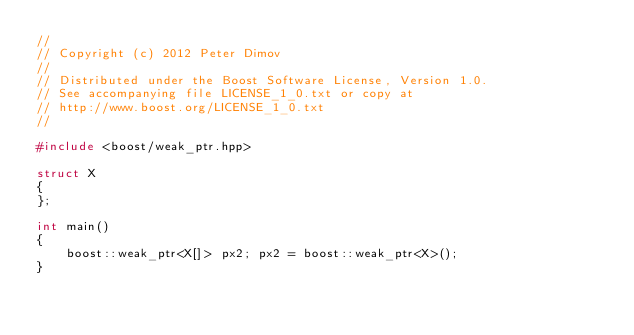Convert code to text. <code><loc_0><loc_0><loc_500><loc_500><_C++_>//
// Copyright (c) 2012 Peter Dimov
//
// Distributed under the Boost Software License, Version 1.0.
// See accompanying file LICENSE_1_0.txt or copy at
// http://www.boost.org/LICENSE_1_0.txt
//

#include <boost/weak_ptr.hpp>

struct X
{
};

int main()
{
    boost::weak_ptr<X[]> px2; px2 = boost::weak_ptr<X>();
}
</code> 